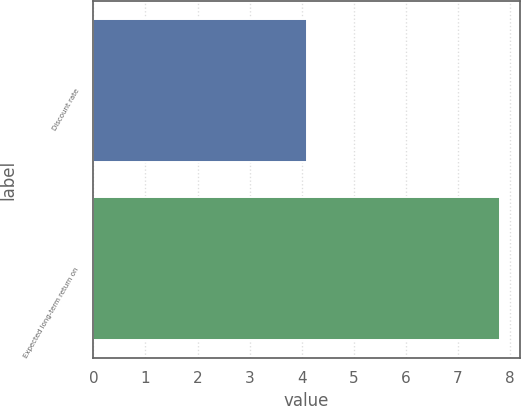Convert chart. <chart><loc_0><loc_0><loc_500><loc_500><bar_chart><fcel>Discount rate<fcel>Expected long-term return on<nl><fcel>4.1<fcel>7.8<nl></chart> 